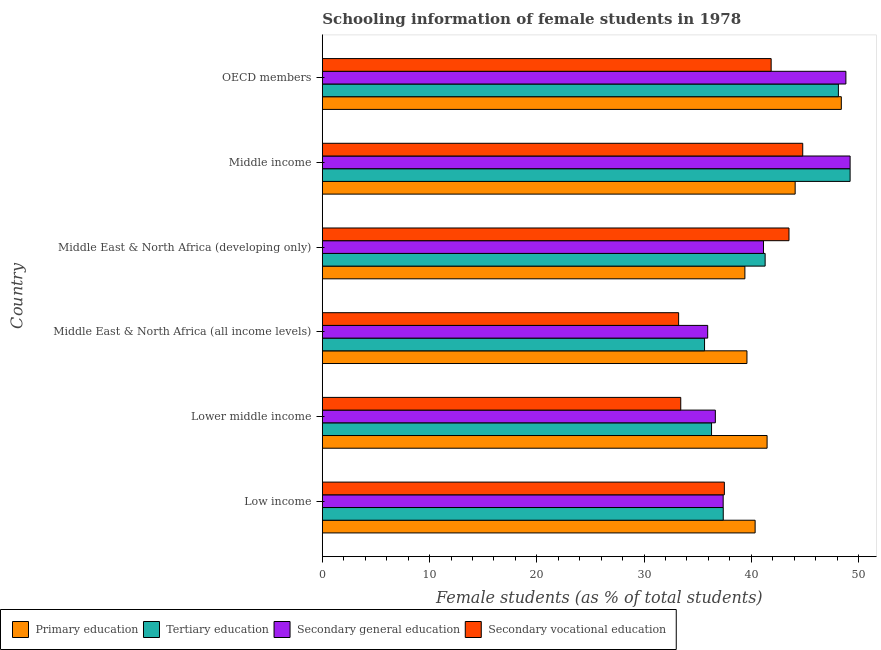Are the number of bars on each tick of the Y-axis equal?
Offer a terse response. Yes. How many bars are there on the 1st tick from the top?
Provide a succinct answer. 4. How many bars are there on the 5th tick from the bottom?
Keep it short and to the point. 4. In how many cases, is the number of bars for a given country not equal to the number of legend labels?
Your answer should be compact. 0. What is the percentage of female students in secondary education in Low income?
Your answer should be very brief. 37.38. Across all countries, what is the maximum percentage of female students in tertiary education?
Keep it short and to the point. 49.21. Across all countries, what is the minimum percentage of female students in secondary vocational education?
Offer a very short reply. 33.22. In which country was the percentage of female students in secondary education minimum?
Provide a short and direct response. Middle East & North Africa (all income levels). What is the total percentage of female students in secondary education in the graph?
Keep it short and to the point. 249.12. What is the difference between the percentage of female students in secondary vocational education in Middle East & North Africa (developing only) and that in OECD members?
Ensure brevity in your answer.  1.66. What is the difference between the percentage of female students in tertiary education in Middle income and the percentage of female students in secondary education in Middle East & North Africa (developing only)?
Provide a succinct answer. 8.08. What is the average percentage of female students in tertiary education per country?
Your response must be concise. 41.32. What is the difference between the percentage of female students in tertiary education and percentage of female students in secondary vocational education in Middle East & North Africa (developing only)?
Provide a short and direct response. -2.22. What is the ratio of the percentage of female students in primary education in Low income to that in OECD members?
Make the answer very short. 0.83. Is the percentage of female students in tertiary education in Middle East & North Africa (all income levels) less than that in Middle East & North Africa (developing only)?
Make the answer very short. Yes. What is the difference between the highest and the second highest percentage of female students in secondary education?
Provide a succinct answer. 0.39. What is the difference between the highest and the lowest percentage of female students in secondary vocational education?
Make the answer very short. 11.57. Is the sum of the percentage of female students in secondary vocational education in Lower middle income and OECD members greater than the maximum percentage of female students in secondary education across all countries?
Offer a very short reply. Yes. Is it the case that in every country, the sum of the percentage of female students in primary education and percentage of female students in secondary education is greater than the sum of percentage of female students in tertiary education and percentage of female students in secondary vocational education?
Your response must be concise. No. What does the 1st bar from the top in Low income represents?
Offer a terse response. Secondary vocational education. What does the 2nd bar from the bottom in Middle East & North Africa (all income levels) represents?
Ensure brevity in your answer.  Tertiary education. Is it the case that in every country, the sum of the percentage of female students in primary education and percentage of female students in tertiary education is greater than the percentage of female students in secondary education?
Keep it short and to the point. Yes. How many bars are there?
Your answer should be compact. 24. Are all the bars in the graph horizontal?
Keep it short and to the point. Yes. What is the difference between two consecutive major ticks on the X-axis?
Give a very brief answer. 10. Are the values on the major ticks of X-axis written in scientific E-notation?
Provide a succinct answer. No. Does the graph contain any zero values?
Give a very brief answer. No. How are the legend labels stacked?
Offer a terse response. Horizontal. What is the title of the graph?
Offer a terse response. Schooling information of female students in 1978. What is the label or title of the X-axis?
Give a very brief answer. Female students (as % of total students). What is the Female students (as % of total students) in Primary education in Low income?
Ensure brevity in your answer.  40.35. What is the Female students (as % of total students) of Tertiary education in Low income?
Provide a succinct answer. 37.38. What is the Female students (as % of total students) of Secondary general education in Low income?
Ensure brevity in your answer.  37.38. What is the Female students (as % of total students) of Secondary vocational education in Low income?
Your response must be concise. 37.49. What is the Female students (as % of total students) of Primary education in Lower middle income?
Keep it short and to the point. 41.47. What is the Female students (as % of total students) in Tertiary education in Lower middle income?
Give a very brief answer. 36.29. What is the Female students (as % of total students) of Secondary general education in Lower middle income?
Provide a succinct answer. 36.65. What is the Female students (as % of total students) of Secondary vocational education in Lower middle income?
Offer a terse response. 33.42. What is the Female students (as % of total students) of Primary education in Middle East & North Africa (all income levels)?
Offer a terse response. 39.59. What is the Female students (as % of total students) in Tertiary education in Middle East & North Africa (all income levels)?
Your answer should be compact. 35.64. What is the Female students (as % of total students) in Secondary general education in Middle East & North Africa (all income levels)?
Provide a short and direct response. 35.93. What is the Female students (as % of total students) of Secondary vocational education in Middle East & North Africa (all income levels)?
Keep it short and to the point. 33.22. What is the Female students (as % of total students) in Primary education in Middle East & North Africa (developing only)?
Keep it short and to the point. 39.4. What is the Female students (as % of total students) of Tertiary education in Middle East & North Africa (developing only)?
Your response must be concise. 41.29. What is the Female students (as % of total students) of Secondary general education in Middle East & North Africa (developing only)?
Ensure brevity in your answer.  41.13. What is the Female students (as % of total students) in Secondary vocational education in Middle East & North Africa (developing only)?
Provide a short and direct response. 43.51. What is the Female students (as % of total students) of Primary education in Middle income?
Your answer should be very brief. 44.09. What is the Female students (as % of total students) in Tertiary education in Middle income?
Offer a terse response. 49.21. What is the Female students (as % of total students) in Secondary general education in Middle income?
Ensure brevity in your answer.  49.21. What is the Female students (as % of total students) of Secondary vocational education in Middle income?
Ensure brevity in your answer.  44.79. What is the Female students (as % of total students) of Primary education in OECD members?
Provide a succinct answer. 48.39. What is the Female students (as % of total students) in Tertiary education in OECD members?
Offer a very short reply. 48.12. What is the Female students (as % of total students) in Secondary general education in OECD members?
Provide a succinct answer. 48.82. What is the Female students (as % of total students) in Secondary vocational education in OECD members?
Offer a very short reply. 41.85. Across all countries, what is the maximum Female students (as % of total students) of Primary education?
Your answer should be very brief. 48.39. Across all countries, what is the maximum Female students (as % of total students) of Tertiary education?
Your answer should be very brief. 49.21. Across all countries, what is the maximum Female students (as % of total students) in Secondary general education?
Provide a short and direct response. 49.21. Across all countries, what is the maximum Female students (as % of total students) of Secondary vocational education?
Provide a short and direct response. 44.79. Across all countries, what is the minimum Female students (as % of total students) of Primary education?
Give a very brief answer. 39.4. Across all countries, what is the minimum Female students (as % of total students) in Tertiary education?
Make the answer very short. 35.64. Across all countries, what is the minimum Female students (as % of total students) in Secondary general education?
Make the answer very short. 35.93. Across all countries, what is the minimum Female students (as % of total students) in Secondary vocational education?
Offer a terse response. 33.22. What is the total Female students (as % of total students) in Primary education in the graph?
Keep it short and to the point. 253.3. What is the total Female students (as % of total students) in Tertiary education in the graph?
Give a very brief answer. 247.93. What is the total Female students (as % of total students) in Secondary general education in the graph?
Your response must be concise. 249.12. What is the total Female students (as % of total students) of Secondary vocational education in the graph?
Offer a terse response. 234.29. What is the difference between the Female students (as % of total students) in Primary education in Low income and that in Lower middle income?
Provide a succinct answer. -1.12. What is the difference between the Female students (as % of total students) of Tertiary education in Low income and that in Lower middle income?
Offer a very short reply. 1.09. What is the difference between the Female students (as % of total students) of Secondary general education in Low income and that in Lower middle income?
Keep it short and to the point. 0.73. What is the difference between the Female students (as % of total students) of Secondary vocational education in Low income and that in Lower middle income?
Your response must be concise. 4.07. What is the difference between the Female students (as % of total students) of Primary education in Low income and that in Middle East & North Africa (all income levels)?
Offer a terse response. 0.76. What is the difference between the Female students (as % of total students) in Tertiary education in Low income and that in Middle East & North Africa (all income levels)?
Your answer should be very brief. 1.74. What is the difference between the Female students (as % of total students) in Secondary general education in Low income and that in Middle East & North Africa (all income levels)?
Make the answer very short. 1.44. What is the difference between the Female students (as % of total students) in Secondary vocational education in Low income and that in Middle East & North Africa (all income levels)?
Keep it short and to the point. 4.26. What is the difference between the Female students (as % of total students) in Primary education in Low income and that in Middle East & North Africa (developing only)?
Provide a short and direct response. 0.95. What is the difference between the Female students (as % of total students) of Tertiary education in Low income and that in Middle East & North Africa (developing only)?
Offer a terse response. -3.91. What is the difference between the Female students (as % of total students) in Secondary general education in Low income and that in Middle East & North Africa (developing only)?
Provide a succinct answer. -3.76. What is the difference between the Female students (as % of total students) of Secondary vocational education in Low income and that in Middle East & North Africa (developing only)?
Offer a very short reply. -6.03. What is the difference between the Female students (as % of total students) in Primary education in Low income and that in Middle income?
Provide a short and direct response. -3.73. What is the difference between the Female students (as % of total students) in Tertiary education in Low income and that in Middle income?
Make the answer very short. -11.83. What is the difference between the Female students (as % of total students) in Secondary general education in Low income and that in Middle income?
Provide a succinct answer. -11.84. What is the difference between the Female students (as % of total students) of Secondary vocational education in Low income and that in Middle income?
Your answer should be very brief. -7.31. What is the difference between the Female students (as % of total students) in Primary education in Low income and that in OECD members?
Give a very brief answer. -8.04. What is the difference between the Female students (as % of total students) in Tertiary education in Low income and that in OECD members?
Offer a very short reply. -10.74. What is the difference between the Female students (as % of total students) of Secondary general education in Low income and that in OECD members?
Your answer should be very brief. -11.44. What is the difference between the Female students (as % of total students) in Secondary vocational education in Low income and that in OECD members?
Offer a terse response. -4.36. What is the difference between the Female students (as % of total students) in Primary education in Lower middle income and that in Middle East & North Africa (all income levels)?
Your answer should be very brief. 1.88. What is the difference between the Female students (as % of total students) in Tertiary education in Lower middle income and that in Middle East & North Africa (all income levels)?
Offer a very short reply. 0.65. What is the difference between the Female students (as % of total students) in Secondary general education in Lower middle income and that in Middle East & North Africa (all income levels)?
Offer a very short reply. 0.71. What is the difference between the Female students (as % of total students) of Secondary vocational education in Lower middle income and that in Middle East & North Africa (all income levels)?
Provide a succinct answer. 0.2. What is the difference between the Female students (as % of total students) of Primary education in Lower middle income and that in Middle East & North Africa (developing only)?
Offer a terse response. 2.07. What is the difference between the Female students (as % of total students) in Tertiary education in Lower middle income and that in Middle East & North Africa (developing only)?
Your response must be concise. -5. What is the difference between the Female students (as % of total students) in Secondary general education in Lower middle income and that in Middle East & North Africa (developing only)?
Provide a short and direct response. -4.49. What is the difference between the Female students (as % of total students) in Secondary vocational education in Lower middle income and that in Middle East & North Africa (developing only)?
Make the answer very short. -10.09. What is the difference between the Female students (as % of total students) in Primary education in Lower middle income and that in Middle income?
Provide a short and direct response. -2.62. What is the difference between the Female students (as % of total students) of Tertiary education in Lower middle income and that in Middle income?
Offer a very short reply. -12.92. What is the difference between the Female students (as % of total students) of Secondary general education in Lower middle income and that in Middle income?
Your answer should be very brief. -12.57. What is the difference between the Female students (as % of total students) of Secondary vocational education in Lower middle income and that in Middle income?
Your answer should be very brief. -11.37. What is the difference between the Female students (as % of total students) in Primary education in Lower middle income and that in OECD members?
Your answer should be very brief. -6.92. What is the difference between the Female students (as % of total students) of Tertiary education in Lower middle income and that in OECD members?
Offer a terse response. -11.83. What is the difference between the Female students (as % of total students) of Secondary general education in Lower middle income and that in OECD members?
Your response must be concise. -12.17. What is the difference between the Female students (as % of total students) of Secondary vocational education in Lower middle income and that in OECD members?
Make the answer very short. -8.43. What is the difference between the Female students (as % of total students) of Primary education in Middle East & North Africa (all income levels) and that in Middle East & North Africa (developing only)?
Your answer should be compact. 0.19. What is the difference between the Female students (as % of total students) of Tertiary education in Middle East & North Africa (all income levels) and that in Middle East & North Africa (developing only)?
Give a very brief answer. -5.65. What is the difference between the Female students (as % of total students) in Secondary general education in Middle East & North Africa (all income levels) and that in Middle East & North Africa (developing only)?
Your answer should be very brief. -5.2. What is the difference between the Female students (as % of total students) of Secondary vocational education in Middle East & North Africa (all income levels) and that in Middle East & North Africa (developing only)?
Ensure brevity in your answer.  -10.29. What is the difference between the Female students (as % of total students) in Primary education in Middle East & North Africa (all income levels) and that in Middle income?
Keep it short and to the point. -4.5. What is the difference between the Female students (as % of total students) in Tertiary education in Middle East & North Africa (all income levels) and that in Middle income?
Ensure brevity in your answer.  -13.57. What is the difference between the Female students (as % of total students) of Secondary general education in Middle East & North Africa (all income levels) and that in Middle income?
Give a very brief answer. -13.28. What is the difference between the Female students (as % of total students) in Secondary vocational education in Middle East & North Africa (all income levels) and that in Middle income?
Provide a short and direct response. -11.57. What is the difference between the Female students (as % of total students) of Primary education in Middle East & North Africa (all income levels) and that in OECD members?
Your response must be concise. -8.8. What is the difference between the Female students (as % of total students) in Tertiary education in Middle East & North Africa (all income levels) and that in OECD members?
Provide a short and direct response. -12.48. What is the difference between the Female students (as % of total students) of Secondary general education in Middle East & North Africa (all income levels) and that in OECD members?
Your response must be concise. -12.89. What is the difference between the Female students (as % of total students) of Secondary vocational education in Middle East & North Africa (all income levels) and that in OECD members?
Your answer should be compact. -8.63. What is the difference between the Female students (as % of total students) in Primary education in Middle East & North Africa (developing only) and that in Middle income?
Keep it short and to the point. -4.69. What is the difference between the Female students (as % of total students) in Tertiary education in Middle East & North Africa (developing only) and that in Middle income?
Your answer should be very brief. -7.92. What is the difference between the Female students (as % of total students) in Secondary general education in Middle East & North Africa (developing only) and that in Middle income?
Your response must be concise. -8.08. What is the difference between the Female students (as % of total students) of Secondary vocational education in Middle East & North Africa (developing only) and that in Middle income?
Your response must be concise. -1.28. What is the difference between the Female students (as % of total students) in Primary education in Middle East & North Africa (developing only) and that in OECD members?
Keep it short and to the point. -8.99. What is the difference between the Female students (as % of total students) in Tertiary education in Middle East & North Africa (developing only) and that in OECD members?
Offer a terse response. -6.83. What is the difference between the Female students (as % of total students) of Secondary general education in Middle East & North Africa (developing only) and that in OECD members?
Provide a succinct answer. -7.68. What is the difference between the Female students (as % of total students) of Secondary vocational education in Middle East & North Africa (developing only) and that in OECD members?
Ensure brevity in your answer.  1.66. What is the difference between the Female students (as % of total students) of Primary education in Middle income and that in OECD members?
Your answer should be very brief. -4.3. What is the difference between the Female students (as % of total students) in Tertiary education in Middle income and that in OECD members?
Ensure brevity in your answer.  1.09. What is the difference between the Female students (as % of total students) in Secondary general education in Middle income and that in OECD members?
Make the answer very short. 0.39. What is the difference between the Female students (as % of total students) in Secondary vocational education in Middle income and that in OECD members?
Keep it short and to the point. 2.94. What is the difference between the Female students (as % of total students) of Primary education in Low income and the Female students (as % of total students) of Tertiary education in Lower middle income?
Give a very brief answer. 4.06. What is the difference between the Female students (as % of total students) in Primary education in Low income and the Female students (as % of total students) in Secondary general education in Lower middle income?
Keep it short and to the point. 3.71. What is the difference between the Female students (as % of total students) of Primary education in Low income and the Female students (as % of total students) of Secondary vocational education in Lower middle income?
Your answer should be very brief. 6.93. What is the difference between the Female students (as % of total students) in Tertiary education in Low income and the Female students (as % of total students) in Secondary general education in Lower middle income?
Your answer should be compact. 0.74. What is the difference between the Female students (as % of total students) of Tertiary education in Low income and the Female students (as % of total students) of Secondary vocational education in Lower middle income?
Offer a terse response. 3.96. What is the difference between the Female students (as % of total students) in Secondary general education in Low income and the Female students (as % of total students) in Secondary vocational education in Lower middle income?
Your answer should be very brief. 3.96. What is the difference between the Female students (as % of total students) in Primary education in Low income and the Female students (as % of total students) in Tertiary education in Middle East & North Africa (all income levels)?
Your response must be concise. 4.72. What is the difference between the Female students (as % of total students) in Primary education in Low income and the Female students (as % of total students) in Secondary general education in Middle East & North Africa (all income levels)?
Your answer should be very brief. 4.42. What is the difference between the Female students (as % of total students) of Primary education in Low income and the Female students (as % of total students) of Secondary vocational education in Middle East & North Africa (all income levels)?
Give a very brief answer. 7.13. What is the difference between the Female students (as % of total students) in Tertiary education in Low income and the Female students (as % of total students) in Secondary general education in Middle East & North Africa (all income levels)?
Ensure brevity in your answer.  1.45. What is the difference between the Female students (as % of total students) in Tertiary education in Low income and the Female students (as % of total students) in Secondary vocational education in Middle East & North Africa (all income levels)?
Your answer should be compact. 4.16. What is the difference between the Female students (as % of total students) in Secondary general education in Low income and the Female students (as % of total students) in Secondary vocational education in Middle East & North Africa (all income levels)?
Your response must be concise. 4.15. What is the difference between the Female students (as % of total students) in Primary education in Low income and the Female students (as % of total students) in Tertiary education in Middle East & North Africa (developing only)?
Your answer should be very brief. -0.93. What is the difference between the Female students (as % of total students) in Primary education in Low income and the Female students (as % of total students) in Secondary general education in Middle East & North Africa (developing only)?
Give a very brief answer. -0.78. What is the difference between the Female students (as % of total students) of Primary education in Low income and the Female students (as % of total students) of Secondary vocational education in Middle East & North Africa (developing only)?
Your answer should be very brief. -3.16. What is the difference between the Female students (as % of total students) of Tertiary education in Low income and the Female students (as % of total students) of Secondary general education in Middle East & North Africa (developing only)?
Offer a terse response. -3.75. What is the difference between the Female students (as % of total students) in Tertiary education in Low income and the Female students (as % of total students) in Secondary vocational education in Middle East & North Africa (developing only)?
Your answer should be compact. -6.13. What is the difference between the Female students (as % of total students) of Secondary general education in Low income and the Female students (as % of total students) of Secondary vocational education in Middle East & North Africa (developing only)?
Your response must be concise. -6.14. What is the difference between the Female students (as % of total students) of Primary education in Low income and the Female students (as % of total students) of Tertiary education in Middle income?
Give a very brief answer. -8.86. What is the difference between the Female students (as % of total students) of Primary education in Low income and the Female students (as % of total students) of Secondary general education in Middle income?
Your answer should be very brief. -8.86. What is the difference between the Female students (as % of total students) of Primary education in Low income and the Female students (as % of total students) of Secondary vocational education in Middle income?
Your response must be concise. -4.44. What is the difference between the Female students (as % of total students) of Tertiary education in Low income and the Female students (as % of total students) of Secondary general education in Middle income?
Ensure brevity in your answer.  -11.83. What is the difference between the Female students (as % of total students) of Tertiary education in Low income and the Female students (as % of total students) of Secondary vocational education in Middle income?
Keep it short and to the point. -7.41. What is the difference between the Female students (as % of total students) in Secondary general education in Low income and the Female students (as % of total students) in Secondary vocational education in Middle income?
Provide a succinct answer. -7.42. What is the difference between the Female students (as % of total students) in Primary education in Low income and the Female students (as % of total students) in Tertiary education in OECD members?
Ensure brevity in your answer.  -7.76. What is the difference between the Female students (as % of total students) of Primary education in Low income and the Female students (as % of total students) of Secondary general education in OECD members?
Provide a succinct answer. -8.46. What is the difference between the Female students (as % of total students) in Primary education in Low income and the Female students (as % of total students) in Secondary vocational education in OECD members?
Provide a succinct answer. -1.49. What is the difference between the Female students (as % of total students) in Tertiary education in Low income and the Female students (as % of total students) in Secondary general education in OECD members?
Offer a terse response. -11.44. What is the difference between the Female students (as % of total students) in Tertiary education in Low income and the Female students (as % of total students) in Secondary vocational education in OECD members?
Make the answer very short. -4.47. What is the difference between the Female students (as % of total students) in Secondary general education in Low income and the Female students (as % of total students) in Secondary vocational education in OECD members?
Provide a short and direct response. -4.47. What is the difference between the Female students (as % of total students) in Primary education in Lower middle income and the Female students (as % of total students) in Tertiary education in Middle East & North Africa (all income levels)?
Keep it short and to the point. 5.83. What is the difference between the Female students (as % of total students) in Primary education in Lower middle income and the Female students (as % of total students) in Secondary general education in Middle East & North Africa (all income levels)?
Offer a terse response. 5.54. What is the difference between the Female students (as % of total students) in Primary education in Lower middle income and the Female students (as % of total students) in Secondary vocational education in Middle East & North Africa (all income levels)?
Keep it short and to the point. 8.25. What is the difference between the Female students (as % of total students) of Tertiary education in Lower middle income and the Female students (as % of total students) of Secondary general education in Middle East & North Africa (all income levels)?
Your answer should be very brief. 0.36. What is the difference between the Female students (as % of total students) in Tertiary education in Lower middle income and the Female students (as % of total students) in Secondary vocational education in Middle East & North Africa (all income levels)?
Offer a terse response. 3.07. What is the difference between the Female students (as % of total students) in Secondary general education in Lower middle income and the Female students (as % of total students) in Secondary vocational education in Middle East & North Africa (all income levels)?
Make the answer very short. 3.42. What is the difference between the Female students (as % of total students) of Primary education in Lower middle income and the Female students (as % of total students) of Tertiary education in Middle East & North Africa (developing only)?
Your answer should be very brief. 0.18. What is the difference between the Female students (as % of total students) of Primary education in Lower middle income and the Female students (as % of total students) of Secondary general education in Middle East & North Africa (developing only)?
Provide a short and direct response. 0.34. What is the difference between the Female students (as % of total students) of Primary education in Lower middle income and the Female students (as % of total students) of Secondary vocational education in Middle East & North Africa (developing only)?
Make the answer very short. -2.04. What is the difference between the Female students (as % of total students) in Tertiary education in Lower middle income and the Female students (as % of total students) in Secondary general education in Middle East & North Africa (developing only)?
Ensure brevity in your answer.  -4.84. What is the difference between the Female students (as % of total students) in Tertiary education in Lower middle income and the Female students (as % of total students) in Secondary vocational education in Middle East & North Africa (developing only)?
Offer a very short reply. -7.22. What is the difference between the Female students (as % of total students) in Secondary general education in Lower middle income and the Female students (as % of total students) in Secondary vocational education in Middle East & North Africa (developing only)?
Provide a short and direct response. -6.87. What is the difference between the Female students (as % of total students) of Primary education in Lower middle income and the Female students (as % of total students) of Tertiary education in Middle income?
Provide a succinct answer. -7.74. What is the difference between the Female students (as % of total students) in Primary education in Lower middle income and the Female students (as % of total students) in Secondary general education in Middle income?
Offer a very short reply. -7.74. What is the difference between the Female students (as % of total students) of Primary education in Lower middle income and the Female students (as % of total students) of Secondary vocational education in Middle income?
Make the answer very short. -3.32. What is the difference between the Female students (as % of total students) of Tertiary education in Lower middle income and the Female students (as % of total students) of Secondary general education in Middle income?
Your response must be concise. -12.92. What is the difference between the Female students (as % of total students) in Tertiary education in Lower middle income and the Female students (as % of total students) in Secondary vocational education in Middle income?
Ensure brevity in your answer.  -8.5. What is the difference between the Female students (as % of total students) in Secondary general education in Lower middle income and the Female students (as % of total students) in Secondary vocational education in Middle income?
Offer a very short reply. -8.15. What is the difference between the Female students (as % of total students) in Primary education in Lower middle income and the Female students (as % of total students) in Tertiary education in OECD members?
Your answer should be very brief. -6.65. What is the difference between the Female students (as % of total students) in Primary education in Lower middle income and the Female students (as % of total students) in Secondary general education in OECD members?
Your answer should be compact. -7.35. What is the difference between the Female students (as % of total students) of Primary education in Lower middle income and the Female students (as % of total students) of Secondary vocational education in OECD members?
Provide a succinct answer. -0.38. What is the difference between the Female students (as % of total students) of Tertiary education in Lower middle income and the Female students (as % of total students) of Secondary general education in OECD members?
Your answer should be very brief. -12.53. What is the difference between the Female students (as % of total students) of Tertiary education in Lower middle income and the Female students (as % of total students) of Secondary vocational education in OECD members?
Give a very brief answer. -5.56. What is the difference between the Female students (as % of total students) of Secondary general education in Lower middle income and the Female students (as % of total students) of Secondary vocational education in OECD members?
Make the answer very short. -5.2. What is the difference between the Female students (as % of total students) in Primary education in Middle East & North Africa (all income levels) and the Female students (as % of total students) in Tertiary education in Middle East & North Africa (developing only)?
Offer a very short reply. -1.7. What is the difference between the Female students (as % of total students) in Primary education in Middle East & North Africa (all income levels) and the Female students (as % of total students) in Secondary general education in Middle East & North Africa (developing only)?
Make the answer very short. -1.54. What is the difference between the Female students (as % of total students) of Primary education in Middle East & North Africa (all income levels) and the Female students (as % of total students) of Secondary vocational education in Middle East & North Africa (developing only)?
Ensure brevity in your answer.  -3.92. What is the difference between the Female students (as % of total students) in Tertiary education in Middle East & North Africa (all income levels) and the Female students (as % of total students) in Secondary general education in Middle East & North Africa (developing only)?
Your answer should be compact. -5.5. What is the difference between the Female students (as % of total students) of Tertiary education in Middle East & North Africa (all income levels) and the Female students (as % of total students) of Secondary vocational education in Middle East & North Africa (developing only)?
Offer a very short reply. -7.87. What is the difference between the Female students (as % of total students) in Secondary general education in Middle East & North Africa (all income levels) and the Female students (as % of total students) in Secondary vocational education in Middle East & North Africa (developing only)?
Provide a short and direct response. -7.58. What is the difference between the Female students (as % of total students) in Primary education in Middle East & North Africa (all income levels) and the Female students (as % of total students) in Tertiary education in Middle income?
Ensure brevity in your answer.  -9.62. What is the difference between the Female students (as % of total students) of Primary education in Middle East & North Africa (all income levels) and the Female students (as % of total students) of Secondary general education in Middle income?
Give a very brief answer. -9.62. What is the difference between the Female students (as % of total students) in Primary education in Middle East & North Africa (all income levels) and the Female students (as % of total students) in Secondary vocational education in Middle income?
Offer a terse response. -5.2. What is the difference between the Female students (as % of total students) in Tertiary education in Middle East & North Africa (all income levels) and the Female students (as % of total students) in Secondary general education in Middle income?
Provide a short and direct response. -13.57. What is the difference between the Female students (as % of total students) of Tertiary education in Middle East & North Africa (all income levels) and the Female students (as % of total students) of Secondary vocational education in Middle income?
Offer a terse response. -9.15. What is the difference between the Female students (as % of total students) of Secondary general education in Middle East & North Africa (all income levels) and the Female students (as % of total students) of Secondary vocational education in Middle income?
Your answer should be compact. -8.86. What is the difference between the Female students (as % of total students) of Primary education in Middle East & North Africa (all income levels) and the Female students (as % of total students) of Tertiary education in OECD members?
Keep it short and to the point. -8.53. What is the difference between the Female students (as % of total students) in Primary education in Middle East & North Africa (all income levels) and the Female students (as % of total students) in Secondary general education in OECD members?
Make the answer very short. -9.23. What is the difference between the Female students (as % of total students) of Primary education in Middle East & North Africa (all income levels) and the Female students (as % of total students) of Secondary vocational education in OECD members?
Your answer should be compact. -2.26. What is the difference between the Female students (as % of total students) in Tertiary education in Middle East & North Africa (all income levels) and the Female students (as % of total students) in Secondary general education in OECD members?
Provide a short and direct response. -13.18. What is the difference between the Female students (as % of total students) in Tertiary education in Middle East & North Africa (all income levels) and the Female students (as % of total students) in Secondary vocational education in OECD members?
Offer a terse response. -6.21. What is the difference between the Female students (as % of total students) in Secondary general education in Middle East & North Africa (all income levels) and the Female students (as % of total students) in Secondary vocational education in OECD members?
Your answer should be very brief. -5.92. What is the difference between the Female students (as % of total students) of Primary education in Middle East & North Africa (developing only) and the Female students (as % of total students) of Tertiary education in Middle income?
Make the answer very short. -9.81. What is the difference between the Female students (as % of total students) of Primary education in Middle East & North Africa (developing only) and the Female students (as % of total students) of Secondary general education in Middle income?
Provide a short and direct response. -9.81. What is the difference between the Female students (as % of total students) of Primary education in Middle East & North Africa (developing only) and the Female students (as % of total students) of Secondary vocational education in Middle income?
Give a very brief answer. -5.39. What is the difference between the Female students (as % of total students) of Tertiary education in Middle East & North Africa (developing only) and the Female students (as % of total students) of Secondary general education in Middle income?
Your response must be concise. -7.92. What is the difference between the Female students (as % of total students) of Tertiary education in Middle East & North Africa (developing only) and the Female students (as % of total students) of Secondary vocational education in Middle income?
Offer a terse response. -3.51. What is the difference between the Female students (as % of total students) of Secondary general education in Middle East & North Africa (developing only) and the Female students (as % of total students) of Secondary vocational education in Middle income?
Give a very brief answer. -3.66. What is the difference between the Female students (as % of total students) in Primary education in Middle East & North Africa (developing only) and the Female students (as % of total students) in Tertiary education in OECD members?
Your response must be concise. -8.72. What is the difference between the Female students (as % of total students) in Primary education in Middle East & North Africa (developing only) and the Female students (as % of total students) in Secondary general education in OECD members?
Give a very brief answer. -9.42. What is the difference between the Female students (as % of total students) of Primary education in Middle East & North Africa (developing only) and the Female students (as % of total students) of Secondary vocational education in OECD members?
Ensure brevity in your answer.  -2.45. What is the difference between the Female students (as % of total students) of Tertiary education in Middle East & North Africa (developing only) and the Female students (as % of total students) of Secondary general education in OECD members?
Keep it short and to the point. -7.53. What is the difference between the Female students (as % of total students) in Tertiary education in Middle East & North Africa (developing only) and the Female students (as % of total students) in Secondary vocational education in OECD members?
Keep it short and to the point. -0.56. What is the difference between the Female students (as % of total students) of Secondary general education in Middle East & North Africa (developing only) and the Female students (as % of total students) of Secondary vocational education in OECD members?
Ensure brevity in your answer.  -0.71. What is the difference between the Female students (as % of total students) in Primary education in Middle income and the Female students (as % of total students) in Tertiary education in OECD members?
Your response must be concise. -4.03. What is the difference between the Female students (as % of total students) of Primary education in Middle income and the Female students (as % of total students) of Secondary general education in OECD members?
Your answer should be very brief. -4.73. What is the difference between the Female students (as % of total students) in Primary education in Middle income and the Female students (as % of total students) in Secondary vocational education in OECD members?
Provide a short and direct response. 2.24. What is the difference between the Female students (as % of total students) of Tertiary education in Middle income and the Female students (as % of total students) of Secondary general education in OECD members?
Your response must be concise. 0.39. What is the difference between the Female students (as % of total students) of Tertiary education in Middle income and the Female students (as % of total students) of Secondary vocational education in OECD members?
Offer a very short reply. 7.36. What is the difference between the Female students (as % of total students) in Secondary general education in Middle income and the Female students (as % of total students) in Secondary vocational education in OECD members?
Your answer should be compact. 7.36. What is the average Female students (as % of total students) in Primary education per country?
Provide a succinct answer. 42.22. What is the average Female students (as % of total students) in Tertiary education per country?
Give a very brief answer. 41.32. What is the average Female students (as % of total students) of Secondary general education per country?
Ensure brevity in your answer.  41.52. What is the average Female students (as % of total students) in Secondary vocational education per country?
Make the answer very short. 39.05. What is the difference between the Female students (as % of total students) of Primary education and Female students (as % of total students) of Tertiary education in Low income?
Keep it short and to the point. 2.97. What is the difference between the Female students (as % of total students) in Primary education and Female students (as % of total students) in Secondary general education in Low income?
Give a very brief answer. 2.98. What is the difference between the Female students (as % of total students) in Primary education and Female students (as % of total students) in Secondary vocational education in Low income?
Provide a short and direct response. 2.87. What is the difference between the Female students (as % of total students) of Tertiary education and Female students (as % of total students) of Secondary general education in Low income?
Make the answer very short. 0.01. What is the difference between the Female students (as % of total students) in Tertiary education and Female students (as % of total students) in Secondary vocational education in Low income?
Ensure brevity in your answer.  -0.1. What is the difference between the Female students (as % of total students) in Secondary general education and Female students (as % of total students) in Secondary vocational education in Low income?
Keep it short and to the point. -0.11. What is the difference between the Female students (as % of total students) in Primary education and Female students (as % of total students) in Tertiary education in Lower middle income?
Keep it short and to the point. 5.18. What is the difference between the Female students (as % of total students) in Primary education and Female students (as % of total students) in Secondary general education in Lower middle income?
Your answer should be very brief. 4.83. What is the difference between the Female students (as % of total students) of Primary education and Female students (as % of total students) of Secondary vocational education in Lower middle income?
Your answer should be compact. 8.05. What is the difference between the Female students (as % of total students) of Tertiary education and Female students (as % of total students) of Secondary general education in Lower middle income?
Your response must be concise. -0.35. What is the difference between the Female students (as % of total students) of Tertiary education and Female students (as % of total students) of Secondary vocational education in Lower middle income?
Keep it short and to the point. 2.87. What is the difference between the Female students (as % of total students) in Secondary general education and Female students (as % of total students) in Secondary vocational education in Lower middle income?
Offer a terse response. 3.23. What is the difference between the Female students (as % of total students) of Primary education and Female students (as % of total students) of Tertiary education in Middle East & North Africa (all income levels)?
Make the answer very short. 3.95. What is the difference between the Female students (as % of total students) in Primary education and Female students (as % of total students) in Secondary general education in Middle East & North Africa (all income levels)?
Offer a very short reply. 3.66. What is the difference between the Female students (as % of total students) in Primary education and Female students (as % of total students) in Secondary vocational education in Middle East & North Africa (all income levels)?
Your answer should be very brief. 6.37. What is the difference between the Female students (as % of total students) in Tertiary education and Female students (as % of total students) in Secondary general education in Middle East & North Africa (all income levels)?
Provide a succinct answer. -0.29. What is the difference between the Female students (as % of total students) of Tertiary education and Female students (as % of total students) of Secondary vocational education in Middle East & North Africa (all income levels)?
Offer a very short reply. 2.42. What is the difference between the Female students (as % of total students) of Secondary general education and Female students (as % of total students) of Secondary vocational education in Middle East & North Africa (all income levels)?
Your answer should be very brief. 2.71. What is the difference between the Female students (as % of total students) in Primary education and Female students (as % of total students) in Tertiary education in Middle East & North Africa (developing only)?
Ensure brevity in your answer.  -1.89. What is the difference between the Female students (as % of total students) of Primary education and Female students (as % of total students) of Secondary general education in Middle East & North Africa (developing only)?
Provide a succinct answer. -1.73. What is the difference between the Female students (as % of total students) of Primary education and Female students (as % of total students) of Secondary vocational education in Middle East & North Africa (developing only)?
Offer a very short reply. -4.11. What is the difference between the Female students (as % of total students) in Tertiary education and Female students (as % of total students) in Secondary general education in Middle East & North Africa (developing only)?
Give a very brief answer. 0.15. What is the difference between the Female students (as % of total students) of Tertiary education and Female students (as % of total students) of Secondary vocational education in Middle East & North Africa (developing only)?
Offer a terse response. -2.22. What is the difference between the Female students (as % of total students) of Secondary general education and Female students (as % of total students) of Secondary vocational education in Middle East & North Africa (developing only)?
Provide a succinct answer. -2.38. What is the difference between the Female students (as % of total students) in Primary education and Female students (as % of total students) in Tertiary education in Middle income?
Ensure brevity in your answer.  -5.12. What is the difference between the Female students (as % of total students) of Primary education and Female students (as % of total students) of Secondary general education in Middle income?
Your response must be concise. -5.12. What is the difference between the Female students (as % of total students) in Primary education and Female students (as % of total students) in Secondary vocational education in Middle income?
Your response must be concise. -0.71. What is the difference between the Female students (as % of total students) of Tertiary education and Female students (as % of total students) of Secondary vocational education in Middle income?
Ensure brevity in your answer.  4.42. What is the difference between the Female students (as % of total students) in Secondary general education and Female students (as % of total students) in Secondary vocational education in Middle income?
Ensure brevity in your answer.  4.42. What is the difference between the Female students (as % of total students) of Primary education and Female students (as % of total students) of Tertiary education in OECD members?
Your response must be concise. 0.27. What is the difference between the Female students (as % of total students) of Primary education and Female students (as % of total students) of Secondary general education in OECD members?
Make the answer very short. -0.43. What is the difference between the Female students (as % of total students) in Primary education and Female students (as % of total students) in Secondary vocational education in OECD members?
Your response must be concise. 6.54. What is the difference between the Female students (as % of total students) of Tertiary education and Female students (as % of total students) of Secondary general education in OECD members?
Your response must be concise. -0.7. What is the difference between the Female students (as % of total students) of Tertiary education and Female students (as % of total students) of Secondary vocational education in OECD members?
Your answer should be very brief. 6.27. What is the difference between the Female students (as % of total students) of Secondary general education and Female students (as % of total students) of Secondary vocational education in OECD members?
Offer a terse response. 6.97. What is the ratio of the Female students (as % of total students) in Primary education in Low income to that in Lower middle income?
Ensure brevity in your answer.  0.97. What is the ratio of the Female students (as % of total students) in Secondary general education in Low income to that in Lower middle income?
Provide a succinct answer. 1.02. What is the ratio of the Female students (as % of total students) in Secondary vocational education in Low income to that in Lower middle income?
Ensure brevity in your answer.  1.12. What is the ratio of the Female students (as % of total students) in Primary education in Low income to that in Middle East & North Africa (all income levels)?
Provide a succinct answer. 1.02. What is the ratio of the Female students (as % of total students) in Tertiary education in Low income to that in Middle East & North Africa (all income levels)?
Offer a terse response. 1.05. What is the ratio of the Female students (as % of total students) of Secondary general education in Low income to that in Middle East & North Africa (all income levels)?
Your answer should be compact. 1.04. What is the ratio of the Female students (as % of total students) in Secondary vocational education in Low income to that in Middle East & North Africa (all income levels)?
Keep it short and to the point. 1.13. What is the ratio of the Female students (as % of total students) of Primary education in Low income to that in Middle East & North Africa (developing only)?
Provide a succinct answer. 1.02. What is the ratio of the Female students (as % of total students) in Tertiary education in Low income to that in Middle East & North Africa (developing only)?
Give a very brief answer. 0.91. What is the ratio of the Female students (as % of total students) of Secondary general education in Low income to that in Middle East & North Africa (developing only)?
Your answer should be compact. 0.91. What is the ratio of the Female students (as % of total students) in Secondary vocational education in Low income to that in Middle East & North Africa (developing only)?
Ensure brevity in your answer.  0.86. What is the ratio of the Female students (as % of total students) of Primary education in Low income to that in Middle income?
Provide a short and direct response. 0.92. What is the ratio of the Female students (as % of total students) in Tertiary education in Low income to that in Middle income?
Your response must be concise. 0.76. What is the ratio of the Female students (as % of total students) of Secondary general education in Low income to that in Middle income?
Ensure brevity in your answer.  0.76. What is the ratio of the Female students (as % of total students) of Secondary vocational education in Low income to that in Middle income?
Offer a very short reply. 0.84. What is the ratio of the Female students (as % of total students) of Primary education in Low income to that in OECD members?
Give a very brief answer. 0.83. What is the ratio of the Female students (as % of total students) in Tertiary education in Low income to that in OECD members?
Keep it short and to the point. 0.78. What is the ratio of the Female students (as % of total students) in Secondary general education in Low income to that in OECD members?
Provide a short and direct response. 0.77. What is the ratio of the Female students (as % of total students) of Secondary vocational education in Low income to that in OECD members?
Make the answer very short. 0.9. What is the ratio of the Female students (as % of total students) of Primary education in Lower middle income to that in Middle East & North Africa (all income levels)?
Give a very brief answer. 1.05. What is the ratio of the Female students (as % of total students) in Tertiary education in Lower middle income to that in Middle East & North Africa (all income levels)?
Your response must be concise. 1.02. What is the ratio of the Female students (as % of total students) of Secondary general education in Lower middle income to that in Middle East & North Africa (all income levels)?
Make the answer very short. 1.02. What is the ratio of the Female students (as % of total students) of Secondary vocational education in Lower middle income to that in Middle East & North Africa (all income levels)?
Ensure brevity in your answer.  1.01. What is the ratio of the Female students (as % of total students) of Primary education in Lower middle income to that in Middle East & North Africa (developing only)?
Your answer should be very brief. 1.05. What is the ratio of the Female students (as % of total students) in Tertiary education in Lower middle income to that in Middle East & North Africa (developing only)?
Offer a terse response. 0.88. What is the ratio of the Female students (as % of total students) of Secondary general education in Lower middle income to that in Middle East & North Africa (developing only)?
Keep it short and to the point. 0.89. What is the ratio of the Female students (as % of total students) in Secondary vocational education in Lower middle income to that in Middle East & North Africa (developing only)?
Provide a short and direct response. 0.77. What is the ratio of the Female students (as % of total students) of Primary education in Lower middle income to that in Middle income?
Your answer should be compact. 0.94. What is the ratio of the Female students (as % of total students) of Tertiary education in Lower middle income to that in Middle income?
Offer a very short reply. 0.74. What is the ratio of the Female students (as % of total students) in Secondary general education in Lower middle income to that in Middle income?
Your response must be concise. 0.74. What is the ratio of the Female students (as % of total students) in Secondary vocational education in Lower middle income to that in Middle income?
Your answer should be compact. 0.75. What is the ratio of the Female students (as % of total students) in Primary education in Lower middle income to that in OECD members?
Provide a short and direct response. 0.86. What is the ratio of the Female students (as % of total students) of Tertiary education in Lower middle income to that in OECD members?
Your answer should be compact. 0.75. What is the ratio of the Female students (as % of total students) in Secondary general education in Lower middle income to that in OECD members?
Make the answer very short. 0.75. What is the ratio of the Female students (as % of total students) of Secondary vocational education in Lower middle income to that in OECD members?
Ensure brevity in your answer.  0.8. What is the ratio of the Female students (as % of total students) in Tertiary education in Middle East & North Africa (all income levels) to that in Middle East & North Africa (developing only)?
Provide a short and direct response. 0.86. What is the ratio of the Female students (as % of total students) of Secondary general education in Middle East & North Africa (all income levels) to that in Middle East & North Africa (developing only)?
Your response must be concise. 0.87. What is the ratio of the Female students (as % of total students) in Secondary vocational education in Middle East & North Africa (all income levels) to that in Middle East & North Africa (developing only)?
Keep it short and to the point. 0.76. What is the ratio of the Female students (as % of total students) of Primary education in Middle East & North Africa (all income levels) to that in Middle income?
Your answer should be very brief. 0.9. What is the ratio of the Female students (as % of total students) in Tertiary education in Middle East & North Africa (all income levels) to that in Middle income?
Keep it short and to the point. 0.72. What is the ratio of the Female students (as % of total students) in Secondary general education in Middle East & North Africa (all income levels) to that in Middle income?
Offer a very short reply. 0.73. What is the ratio of the Female students (as % of total students) in Secondary vocational education in Middle East & North Africa (all income levels) to that in Middle income?
Keep it short and to the point. 0.74. What is the ratio of the Female students (as % of total students) of Primary education in Middle East & North Africa (all income levels) to that in OECD members?
Your answer should be compact. 0.82. What is the ratio of the Female students (as % of total students) of Tertiary education in Middle East & North Africa (all income levels) to that in OECD members?
Your answer should be compact. 0.74. What is the ratio of the Female students (as % of total students) in Secondary general education in Middle East & North Africa (all income levels) to that in OECD members?
Keep it short and to the point. 0.74. What is the ratio of the Female students (as % of total students) of Secondary vocational education in Middle East & North Africa (all income levels) to that in OECD members?
Give a very brief answer. 0.79. What is the ratio of the Female students (as % of total students) of Primary education in Middle East & North Africa (developing only) to that in Middle income?
Offer a terse response. 0.89. What is the ratio of the Female students (as % of total students) of Tertiary education in Middle East & North Africa (developing only) to that in Middle income?
Provide a short and direct response. 0.84. What is the ratio of the Female students (as % of total students) in Secondary general education in Middle East & North Africa (developing only) to that in Middle income?
Provide a short and direct response. 0.84. What is the ratio of the Female students (as % of total students) in Secondary vocational education in Middle East & North Africa (developing only) to that in Middle income?
Your answer should be compact. 0.97. What is the ratio of the Female students (as % of total students) in Primary education in Middle East & North Africa (developing only) to that in OECD members?
Give a very brief answer. 0.81. What is the ratio of the Female students (as % of total students) of Tertiary education in Middle East & North Africa (developing only) to that in OECD members?
Keep it short and to the point. 0.86. What is the ratio of the Female students (as % of total students) of Secondary general education in Middle East & North Africa (developing only) to that in OECD members?
Give a very brief answer. 0.84. What is the ratio of the Female students (as % of total students) in Secondary vocational education in Middle East & North Africa (developing only) to that in OECD members?
Your response must be concise. 1.04. What is the ratio of the Female students (as % of total students) of Primary education in Middle income to that in OECD members?
Provide a short and direct response. 0.91. What is the ratio of the Female students (as % of total students) of Tertiary education in Middle income to that in OECD members?
Keep it short and to the point. 1.02. What is the ratio of the Female students (as % of total students) in Secondary vocational education in Middle income to that in OECD members?
Keep it short and to the point. 1.07. What is the difference between the highest and the second highest Female students (as % of total students) in Primary education?
Provide a short and direct response. 4.3. What is the difference between the highest and the second highest Female students (as % of total students) in Tertiary education?
Your answer should be very brief. 1.09. What is the difference between the highest and the second highest Female students (as % of total students) of Secondary general education?
Ensure brevity in your answer.  0.39. What is the difference between the highest and the second highest Female students (as % of total students) of Secondary vocational education?
Ensure brevity in your answer.  1.28. What is the difference between the highest and the lowest Female students (as % of total students) of Primary education?
Provide a succinct answer. 8.99. What is the difference between the highest and the lowest Female students (as % of total students) of Tertiary education?
Give a very brief answer. 13.57. What is the difference between the highest and the lowest Female students (as % of total students) in Secondary general education?
Offer a terse response. 13.28. What is the difference between the highest and the lowest Female students (as % of total students) of Secondary vocational education?
Your answer should be very brief. 11.57. 